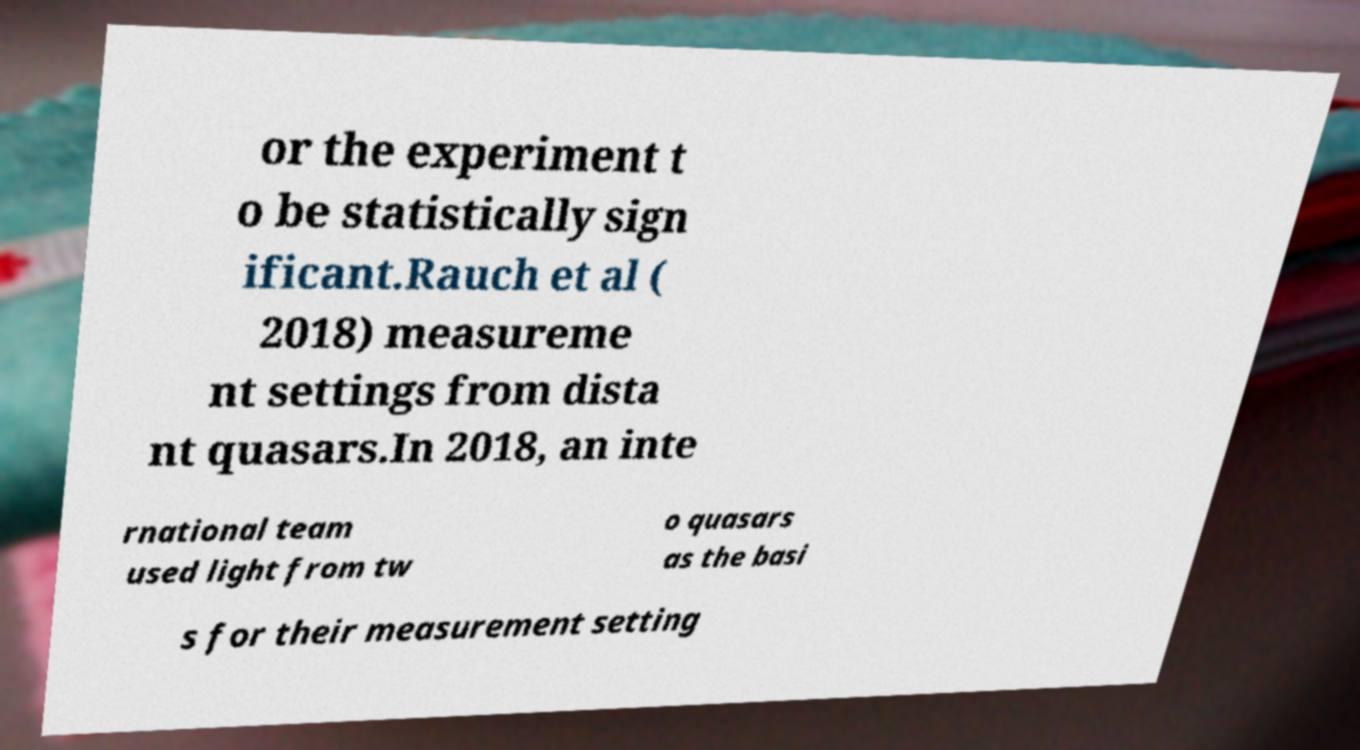Please identify and transcribe the text found in this image. or the experiment t o be statistically sign ificant.Rauch et al ( 2018) measureme nt settings from dista nt quasars.In 2018, an inte rnational team used light from tw o quasars as the basi s for their measurement setting 